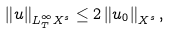<formula> <loc_0><loc_0><loc_500><loc_500>\left \| u \right \| _ { L ^ { \infty } _ { T } X ^ { s } } \leq 2 \left \| u _ { 0 } \right \| _ { X ^ { s } } ,</formula> 